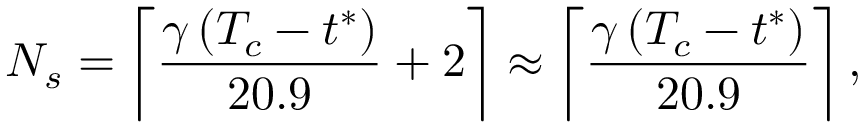Convert formula to latex. <formula><loc_0><loc_0><loc_500><loc_500>N _ { s } = \left \lceil \frac { \gamma \, ( T _ { c } - t ^ { * } ) } { 2 0 . 9 } + 2 \right \rceil \approx \left \lceil \frac { \gamma \, ( T _ { c } - t ^ { * } ) } { 2 0 . 9 } \right \rceil ,</formula> 